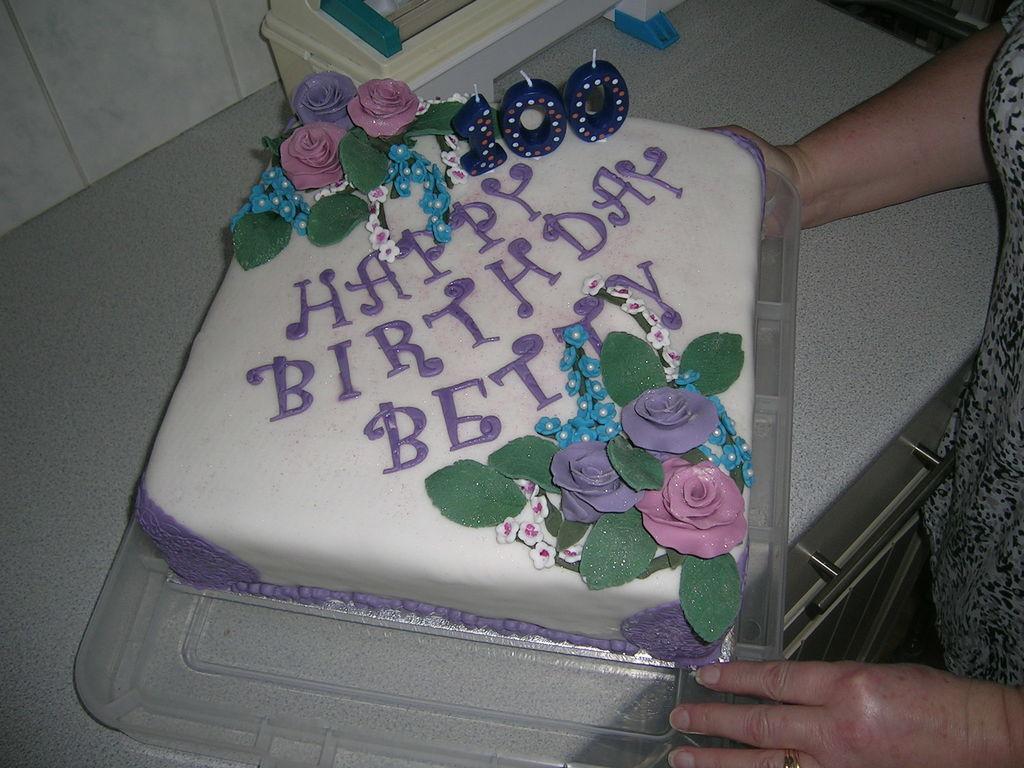Can you describe this image briefly? In this picture we can see a cake on a tray with candles on it and beside this cake we can see an object and a person standing. 